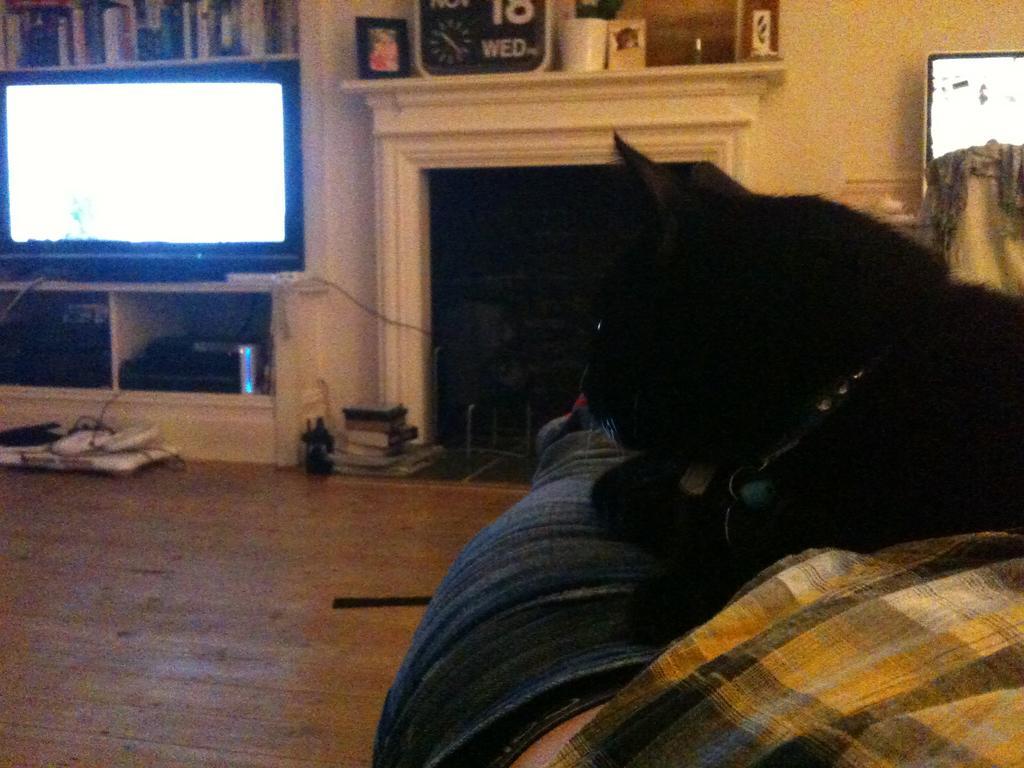How would you summarize this image in a sentence or two? In this image I see a cat which is of black in color and it is sitting on a couch and I see a brown colored floor. In the background I see a white color wall and there is rack over here in which there are books and there is a TV and few things over here. 